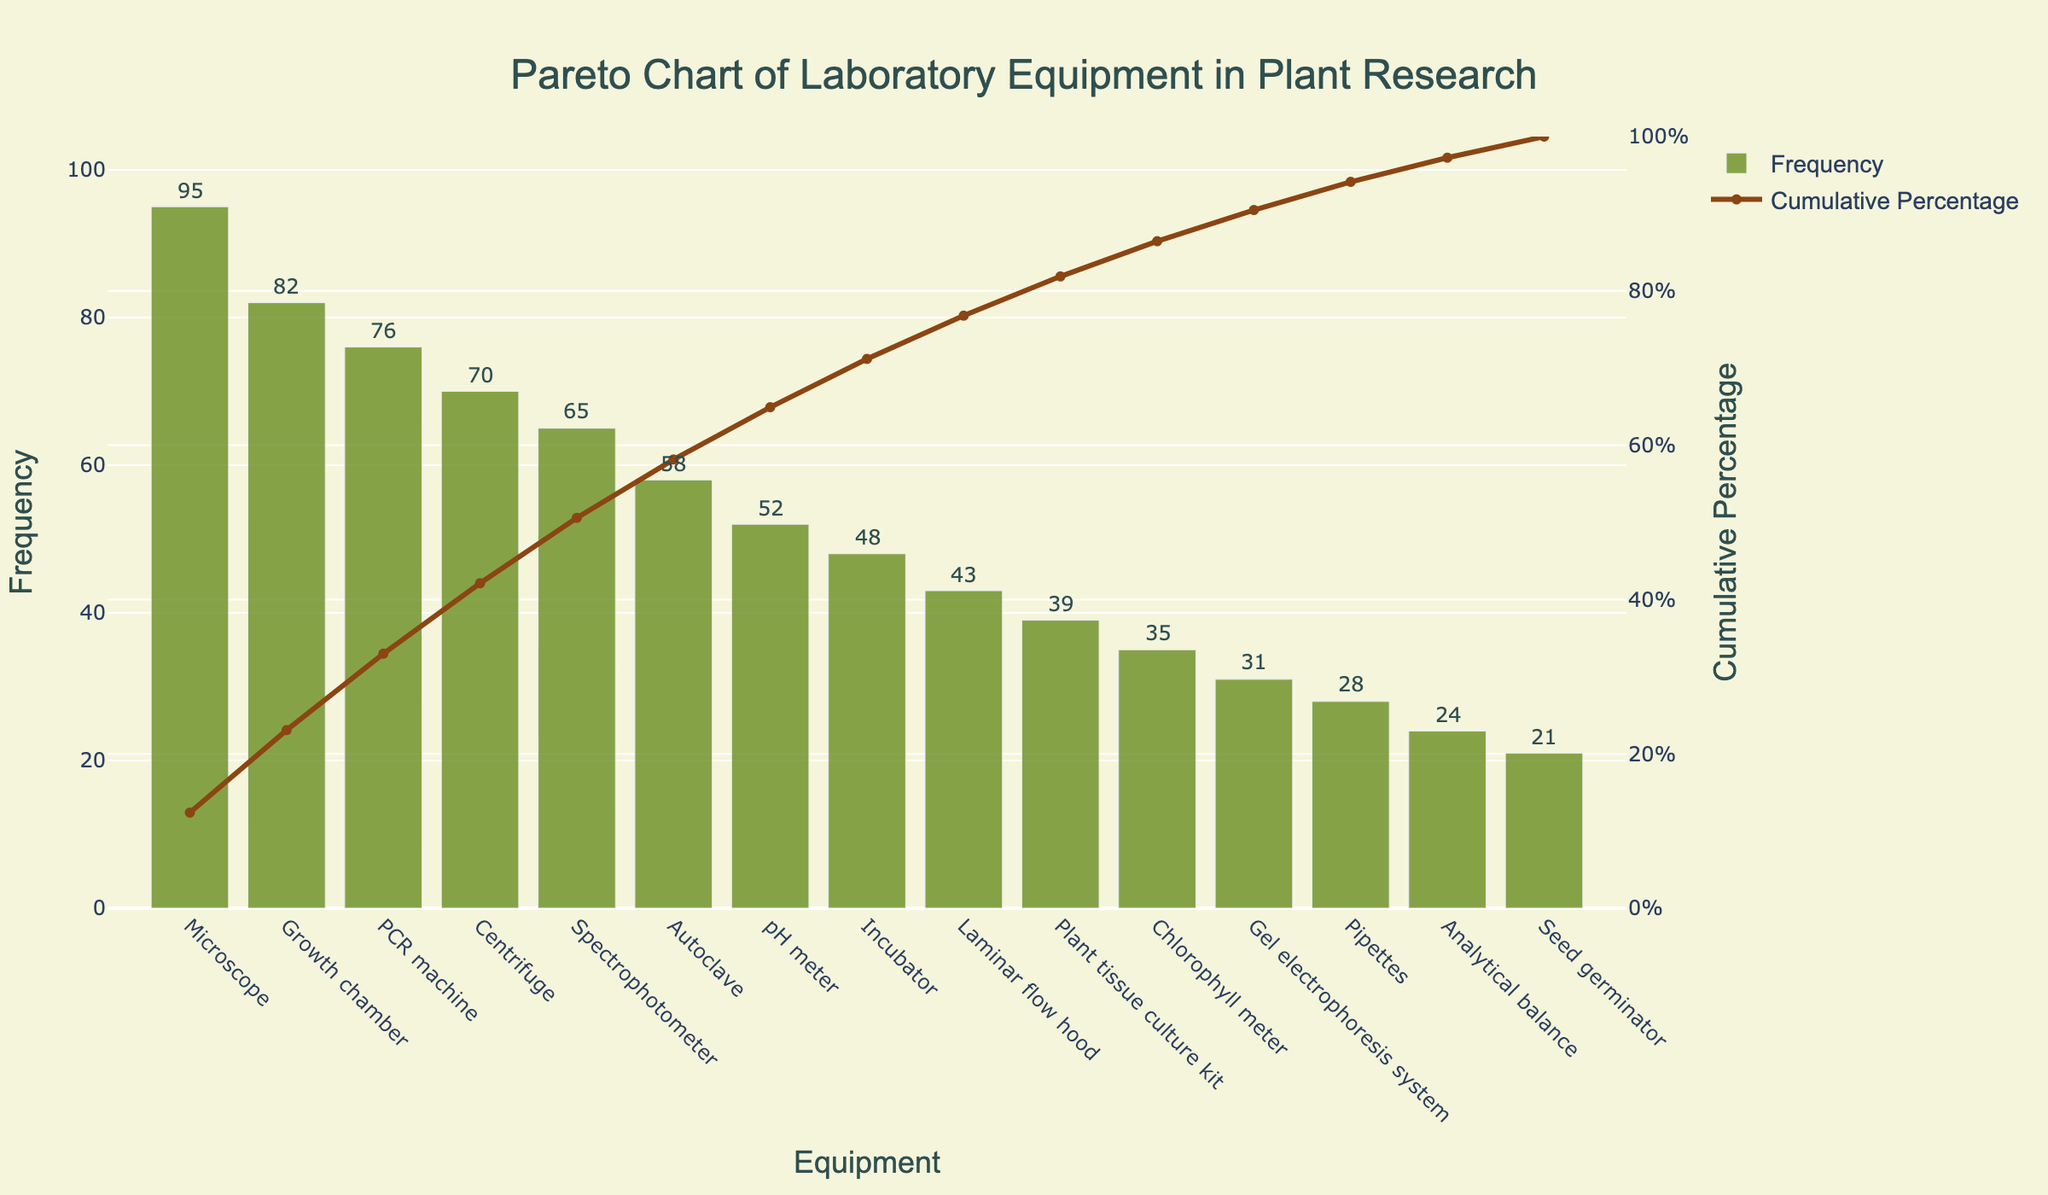What is the maximum frequency value for a piece of equipment? To find the maximum frequency value, look for the highest bar in the chart. The Microscope bar reaches the highest value, which is 95.
Answer: 95 What percentage of the total frequency is covered by the top three equipment types? Add together the frequencies of the Microscope, Growth Chamber, and PCR Machine (95 + 82 + 76 = 253). Then, divide this sum by the total sum of frequencies (95 + 82 + 76 + 70 + 65 + 58 + 52 + 48 + 43 + 39 + 35 + 31 + 28 + 24 + 21 = 767) and multiply by 100. (253 / 767 * 100 ≈ 32.99%). Therefore, the top three equipment types cover approximately 33%.
Answer: 33% Which equipment type has a cumulative percentage closest to 50%? Look down the cumulative percentage line to see which equipment type has a cumulative percentage nearest to 50%. The PCR Machine has a cumulative percentage closest to 50%.
Answer: PCR Machine How does the frequency of the Centrifuge compare to the pH Meter? Locate the bars for Centrifuge and pH Meter. The Centrifuge has a frequency of 70 and the pH Meter has a frequency of 52. The Centrifuge's frequency is greater than the pH Meter's frequency.
Answer: Centrifuge > pH Meter What is the cumulative percentage for the Autoclave? Find the point on the cumulative line that aligns with the Autoclave’s position. The cumulative percentage for Autoclave is a bit higher than 60%.
Answer: Just above 60% Which equipment type has the lowest frequency and what is its value? Look for the shortest bar in the chart. The Seed Germinator has the lowest frequency, which is 21.
Answer: Seed Germinator, 21 How many equipment types have a frequency over 50? Count the bars which exceed a height of 50. There are seven types: Microscope, Growth Chamber, PCR Machine, Centrifuge, Spectrophotometer, Autoclave, and pH Meter.
Answer: 7 What is the cumulative percentage for the equipment with the third highest frequency? The equipment with the third highest frequency is the PCR Machine. The cumulative percentage for PCR Machine is close to 50%.
Answer: Close to 50% What is the difference in frequency between the Spectrophotometer and the Incubator? Find the bars corresponding to the Spectrophotometer (65) and the Incubator (48). Subtract the frequency of the Incubator from that of the Spectrophotometer (65 - 48 = 17).
Answer: 17 Which piece of equipment reaches a cumulative percentage of approximately 20%? Trace the cumulative percentage line down to around 20% and find the corresponding equipment type. The Growth Chamber reaches around 20%.
Answer: Growth Chamber 